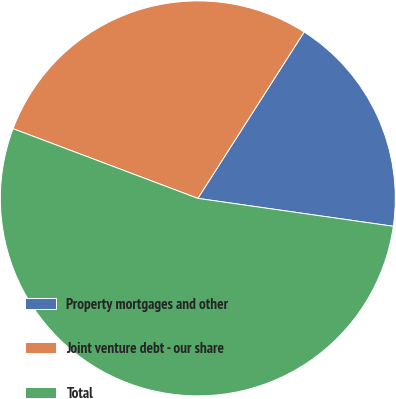<chart> <loc_0><loc_0><loc_500><loc_500><pie_chart><fcel>Property mortgages and other<fcel>Joint venture debt - our share<fcel>Total<nl><fcel>18.21%<fcel>28.31%<fcel>53.48%<nl></chart> 